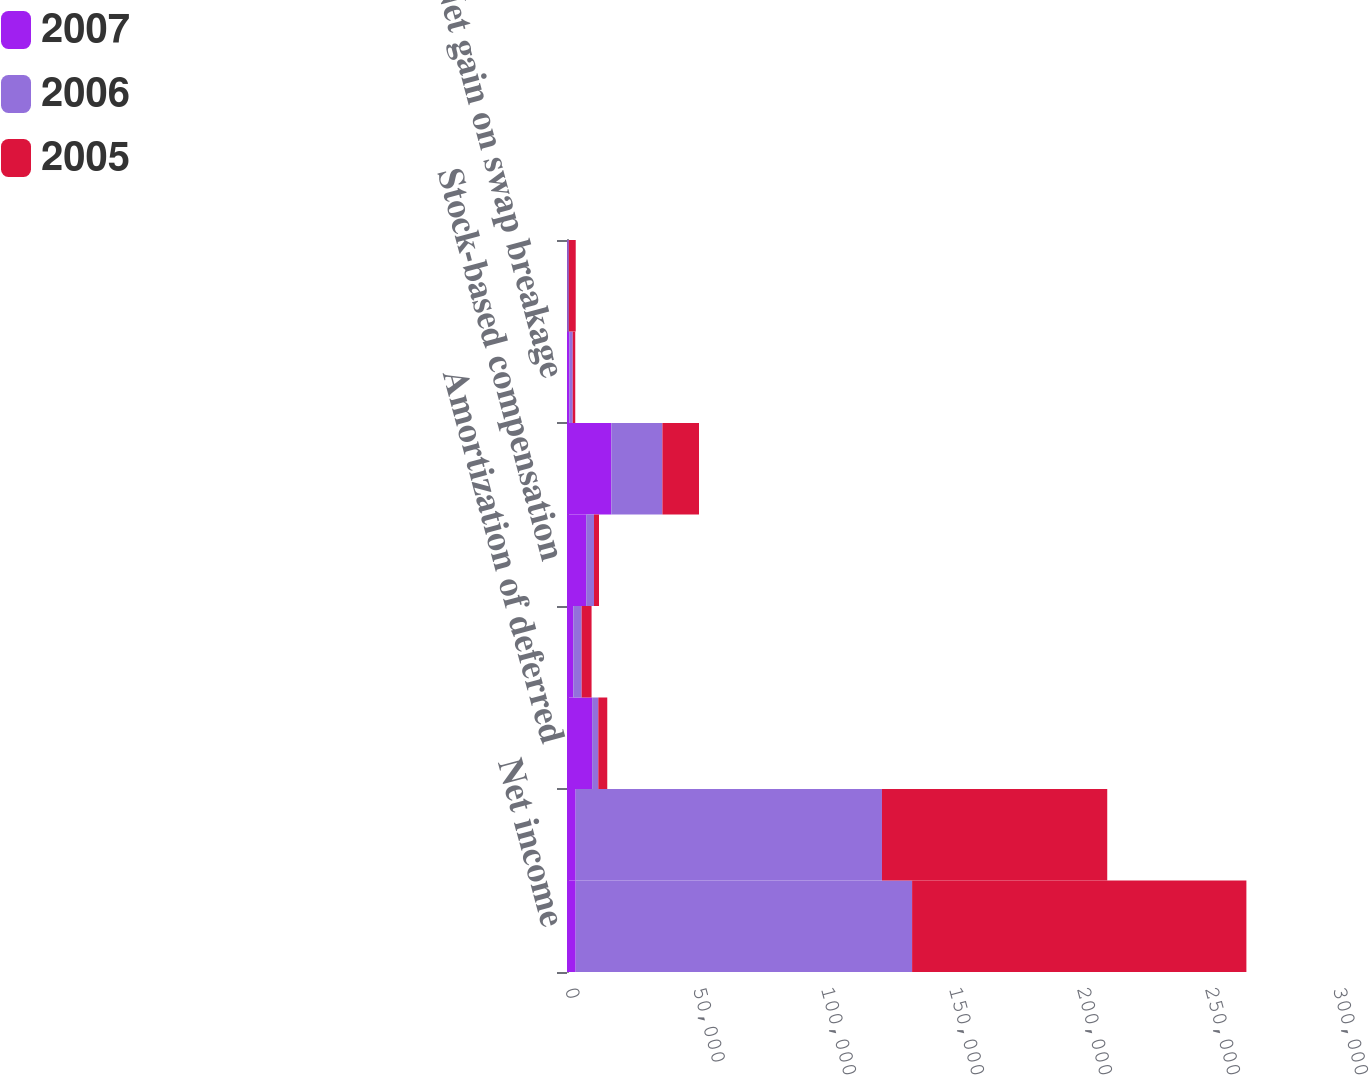<chart> <loc_0><loc_0><loc_500><loc_500><stacked_bar_chart><ecel><fcel>Net income<fcel>Depreciation and amortization<fcel>Amortization of deferred<fcel>Other amortization expenses<fcel>Stock-based compensation<fcel>Straight-lining of rental<fcel>Net gain on swap breakage<fcel>Other<nl><fcel>2007<fcel>3375<fcel>3375<fcel>9819<fcel>2456<fcel>7493<fcel>17311<fcel>864<fcel>222<nl><fcel>2006<fcel>131430<fcel>119653<fcel>2412<fcel>3253<fcel>3046<fcel>19963<fcel>1379<fcel>488<nl><fcel>2005<fcel>130583<fcel>88002<fcel>3497<fcel>3891<fcel>1971<fcel>14287<fcel>981<fcel>2698<nl></chart> 